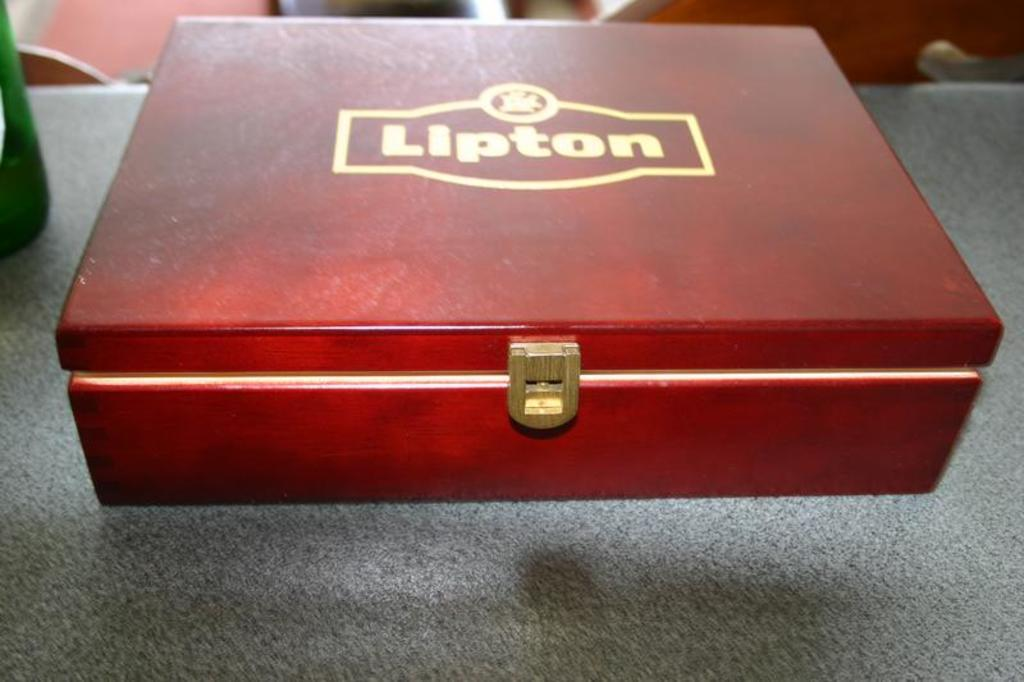<image>
Present a compact description of the photo's key features. lipton tea wooden box sits on the counter 